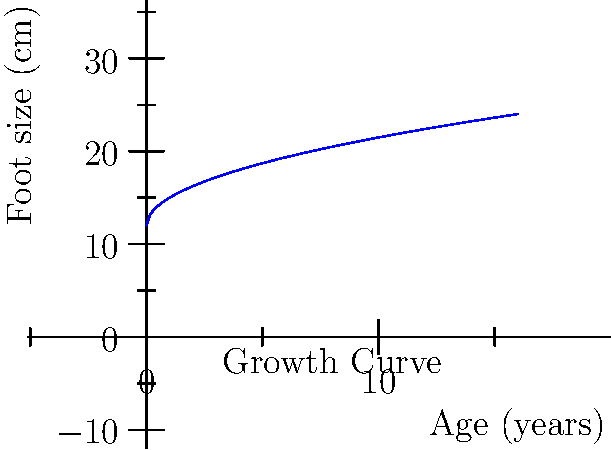The graph shows the foot size of a child as a function of age. At what age is the rate of foot growth exactly 0.5 cm per year? To solve this problem, we need to follow these steps:

1) The foot size function is given by $f(x) = 12 + 3\sqrt{x}$, where $x$ is age in years and $f(x)$ is foot size in cm.

2) The rate of growth is the derivative of this function:
   $f'(x) = \frac{3}{2\sqrt{x}}$

3) We want to find when this rate equals 0.5 cm/year:
   $\frac{3}{2\sqrt{x}} = 0.5$

4) Solve this equation:
   $3 = \sqrt{x}$
   $9 = x$

5) Therefore, at 9 years old, the rate of foot growth is exactly 0.5 cm per year.

6) We can verify:
   $f'(9) = \frac{3}{2\sqrt{9}} = \frac{3}{2(3)} = 0.5$
Answer: 9 years 